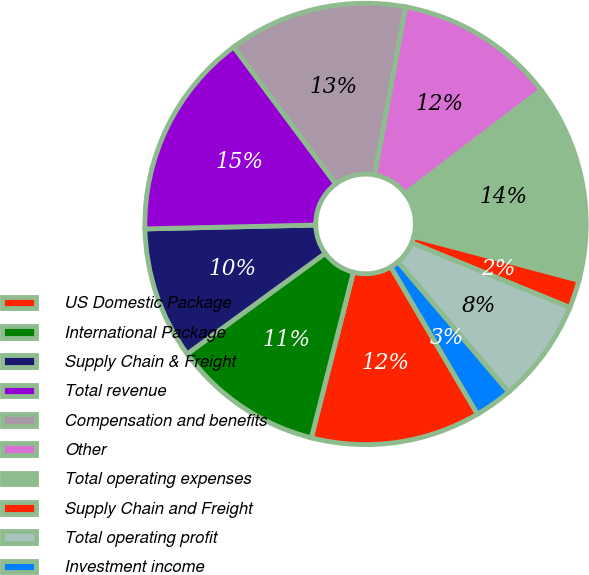Convert chart to OTSL. <chart><loc_0><loc_0><loc_500><loc_500><pie_chart><fcel>US Domestic Package<fcel>International Package<fcel>Supply Chain & Freight<fcel>Total revenue<fcel>Compensation and benefits<fcel>Other<fcel>Total operating expenses<fcel>Supply Chain and Freight<fcel>Total operating profit<fcel>Investment income<nl><fcel>12.41%<fcel>11.03%<fcel>9.66%<fcel>15.17%<fcel>13.1%<fcel>11.72%<fcel>14.48%<fcel>2.07%<fcel>7.59%<fcel>2.76%<nl></chart> 